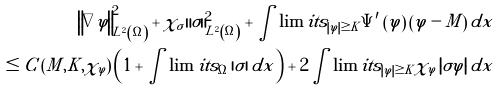<formula> <loc_0><loc_0><loc_500><loc_500>\left \| \nabla \varphi \right \| _ { L ^ { 2 } \left ( \Omega \right ) } ^ { 2 } + { \chi } _ { \sigma } \left \| \sigma \right \| _ { L ^ { 2 } \left ( \Omega \right ) } ^ { 2 } + \int \lim i t s _ { \left | \varphi \right | \geq K } \Psi ^ { \prime } \left ( \varphi \right ) \left ( \varphi - M \right ) d x \\ \leq C \left ( M , K , { \chi } _ { \varphi } \right ) \left ( 1 + \int \lim i t s _ { \Omega } \left | \sigma \right | d x \right ) + 2 \int \lim i t s _ { \left | \varphi \right | \geq K } { \chi } _ { \varphi } \left | \sigma \varphi \right | d x</formula> 